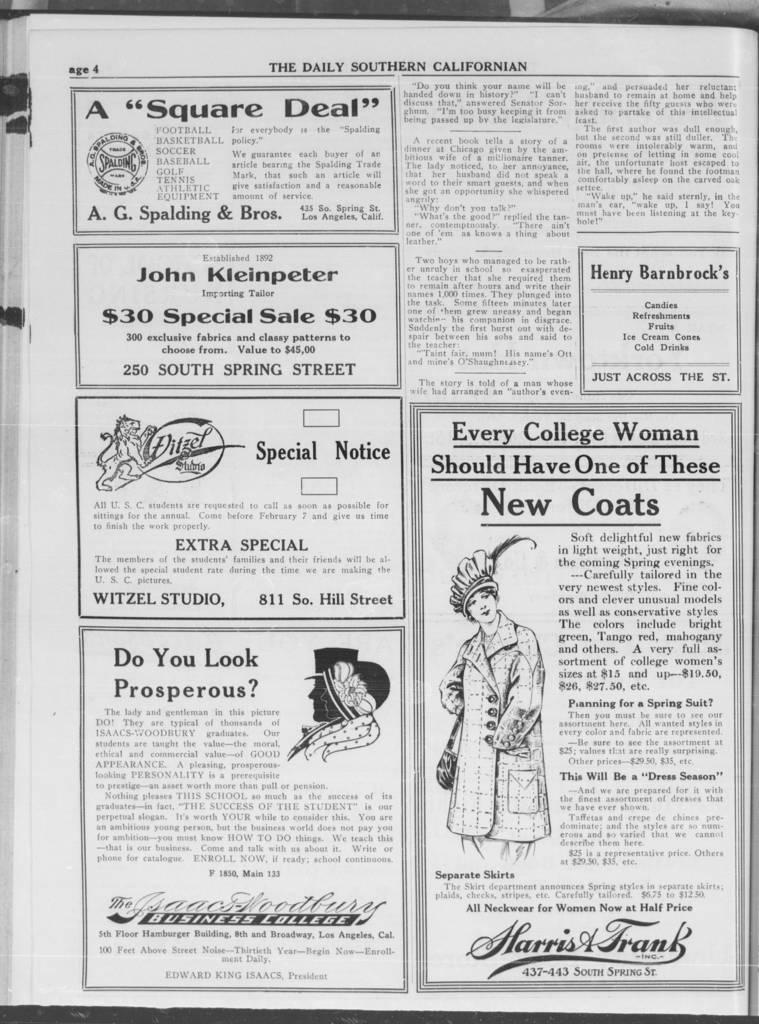Can you describe this image briefly? In this image we can see there is a page of a book with some text and images. 